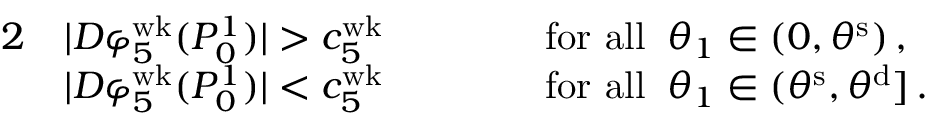Convert formula to latex. <formula><loc_0><loc_0><loc_500><loc_500>\begin{array} { r l r l } { 2 } & { | D \varphi _ { 5 } ^ { w k } ( P _ { 0 } ^ { 1 } ) | > c _ { 5 } ^ { w k } \, \quad } & & { f o r a l l \, \theta _ { 1 } \in ( 0 , \theta ^ { s } ) \, , } \\ & { | D \varphi _ { 5 } ^ { w k } ( P _ { 0 } ^ { 1 } ) | < c _ { 5 } ^ { w k } \, \quad } & & { f o r a l l \, \theta _ { 1 } \in ( \theta ^ { s } , \theta ^ { d } ] \, . } \end{array}</formula> 